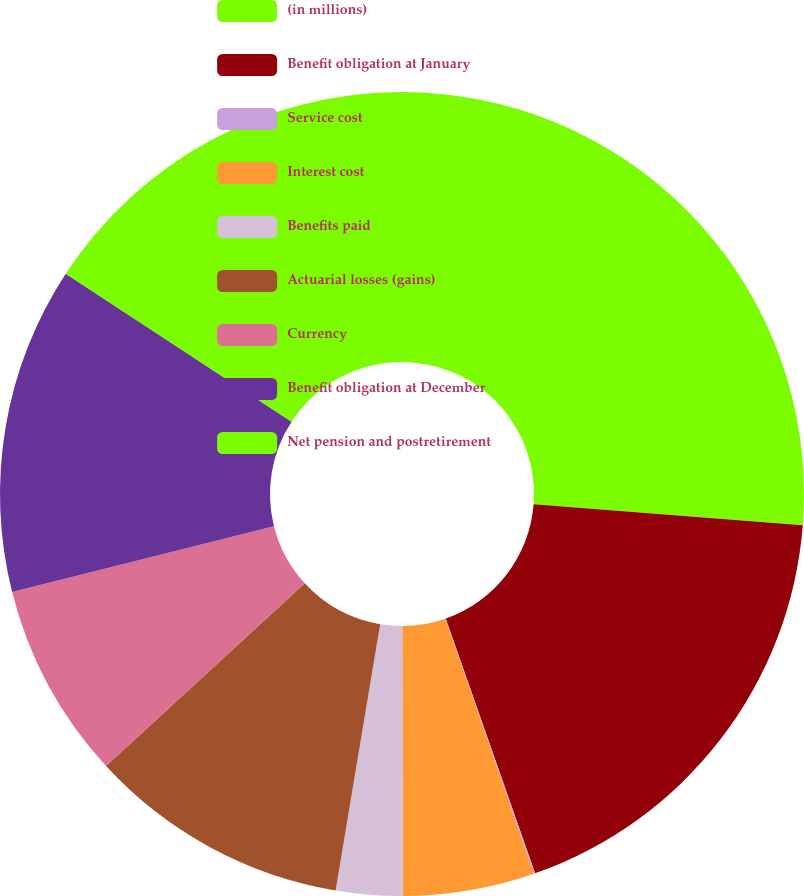Convert chart. <chart><loc_0><loc_0><loc_500><loc_500><pie_chart><fcel>(in millions)<fcel>Benefit obligation at January<fcel>Service cost<fcel>Interest cost<fcel>Benefits paid<fcel>Actuarial losses (gains)<fcel>Currency<fcel>Benefit obligation at December<fcel>Net pension and postretirement<nl><fcel>26.24%<fcel>18.39%<fcel>0.05%<fcel>5.29%<fcel>2.67%<fcel>10.53%<fcel>7.91%<fcel>13.15%<fcel>15.77%<nl></chart> 